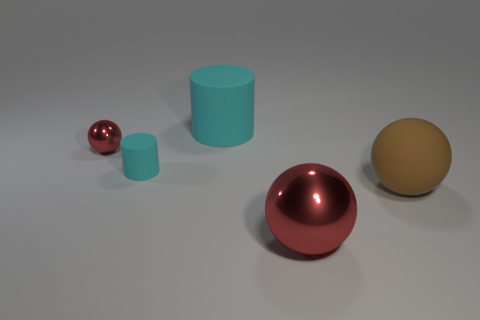Add 4 small brown metal spheres. How many objects exist? 9 Subtract all large spheres. How many spheres are left? 1 Subtract all brown spheres. How many spheres are left? 2 Subtract 1 cylinders. How many cylinders are left? 1 Subtract all balls. How many objects are left? 2 Subtract all yellow spheres. Subtract all yellow cubes. How many spheres are left? 3 Subtract all red cylinders. How many brown balls are left? 1 Subtract all cyan cylinders. Subtract all tiny cyan objects. How many objects are left? 2 Add 4 tiny matte cylinders. How many tiny matte cylinders are left? 5 Add 2 cyan things. How many cyan things exist? 4 